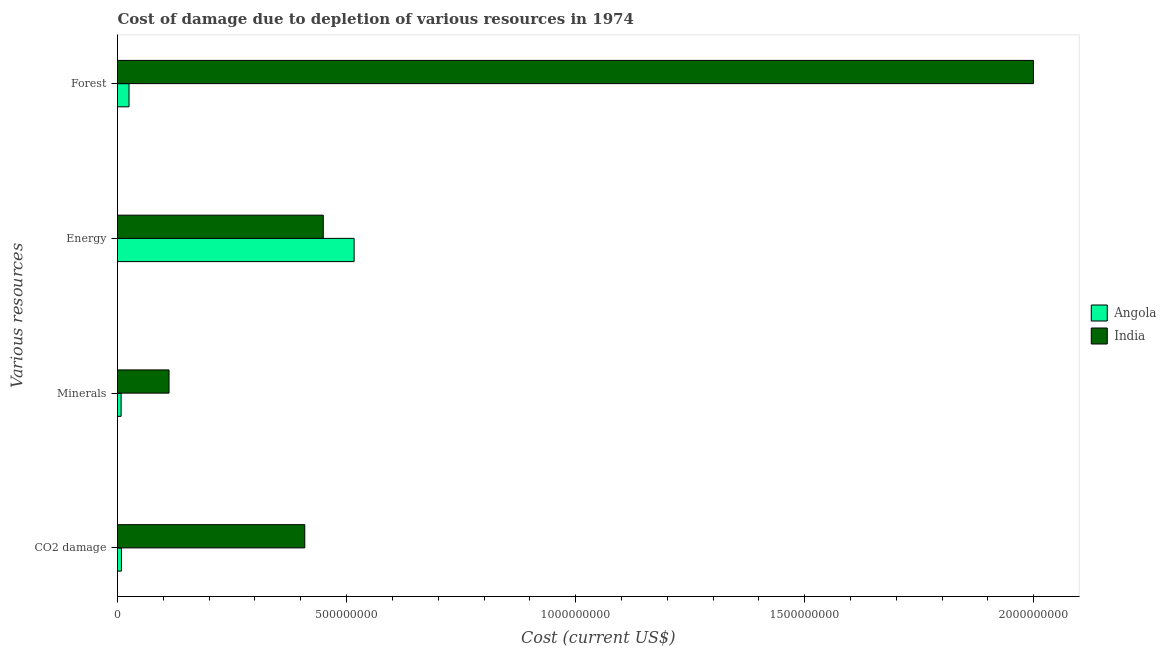How many different coloured bars are there?
Provide a succinct answer. 2. How many groups of bars are there?
Keep it short and to the point. 4. Are the number of bars per tick equal to the number of legend labels?
Offer a terse response. Yes. Are the number of bars on each tick of the Y-axis equal?
Your answer should be compact. Yes. How many bars are there on the 4th tick from the top?
Keep it short and to the point. 2. What is the label of the 3rd group of bars from the top?
Offer a very short reply. Minerals. What is the cost of damage due to depletion of energy in India?
Ensure brevity in your answer.  4.49e+08. Across all countries, what is the maximum cost of damage due to depletion of forests?
Give a very brief answer. 2.00e+09. Across all countries, what is the minimum cost of damage due to depletion of minerals?
Make the answer very short. 7.87e+06. In which country was the cost of damage due to depletion of energy maximum?
Your response must be concise. Angola. In which country was the cost of damage due to depletion of forests minimum?
Make the answer very short. Angola. What is the total cost of damage due to depletion of coal in the graph?
Your response must be concise. 4.17e+08. What is the difference between the cost of damage due to depletion of coal in India and that in Angola?
Keep it short and to the point. 4.00e+08. What is the difference between the cost of damage due to depletion of energy in India and the cost of damage due to depletion of forests in Angola?
Offer a terse response. 4.24e+08. What is the average cost of damage due to depletion of minerals per country?
Keep it short and to the point. 6.02e+07. What is the difference between the cost of damage due to depletion of energy and cost of damage due to depletion of forests in India?
Offer a very short reply. -1.55e+09. What is the ratio of the cost of damage due to depletion of coal in India to that in Angola?
Keep it short and to the point. 47.6. Is the cost of damage due to depletion of forests in Angola less than that in India?
Make the answer very short. Yes. Is the difference between the cost of damage due to depletion of minerals in Angola and India greater than the difference between the cost of damage due to depletion of forests in Angola and India?
Your answer should be very brief. Yes. What is the difference between the highest and the second highest cost of damage due to depletion of forests?
Your answer should be compact. 1.97e+09. What is the difference between the highest and the lowest cost of damage due to depletion of forests?
Your response must be concise. 1.97e+09. In how many countries, is the cost of damage due to depletion of coal greater than the average cost of damage due to depletion of coal taken over all countries?
Give a very brief answer. 1. Is the sum of the cost of damage due to depletion of minerals in India and Angola greater than the maximum cost of damage due to depletion of coal across all countries?
Offer a very short reply. No. What does the 2nd bar from the top in CO2 damage represents?
Your answer should be compact. Angola. What does the 1st bar from the bottom in Energy represents?
Ensure brevity in your answer.  Angola. Is it the case that in every country, the sum of the cost of damage due to depletion of coal and cost of damage due to depletion of minerals is greater than the cost of damage due to depletion of energy?
Provide a succinct answer. No. Are the values on the major ticks of X-axis written in scientific E-notation?
Keep it short and to the point. No. Where does the legend appear in the graph?
Your answer should be very brief. Center right. How many legend labels are there?
Make the answer very short. 2. What is the title of the graph?
Your answer should be very brief. Cost of damage due to depletion of various resources in 1974 . What is the label or title of the X-axis?
Ensure brevity in your answer.  Cost (current US$). What is the label or title of the Y-axis?
Ensure brevity in your answer.  Various resources. What is the Cost (current US$) of Angola in CO2 damage?
Ensure brevity in your answer.  8.59e+06. What is the Cost (current US$) of India in CO2 damage?
Provide a succinct answer. 4.09e+08. What is the Cost (current US$) of Angola in Minerals?
Ensure brevity in your answer.  7.87e+06. What is the Cost (current US$) of India in Minerals?
Give a very brief answer. 1.12e+08. What is the Cost (current US$) of Angola in Energy?
Offer a terse response. 5.16e+08. What is the Cost (current US$) in India in Energy?
Keep it short and to the point. 4.49e+08. What is the Cost (current US$) in Angola in Forest?
Make the answer very short. 2.51e+07. What is the Cost (current US$) in India in Forest?
Ensure brevity in your answer.  2.00e+09. Across all Various resources, what is the maximum Cost (current US$) in Angola?
Your answer should be compact. 5.16e+08. Across all Various resources, what is the maximum Cost (current US$) in India?
Your response must be concise. 2.00e+09. Across all Various resources, what is the minimum Cost (current US$) of Angola?
Provide a short and direct response. 7.87e+06. Across all Various resources, what is the minimum Cost (current US$) of India?
Offer a terse response. 1.12e+08. What is the total Cost (current US$) in Angola in the graph?
Provide a short and direct response. 5.58e+08. What is the total Cost (current US$) in India in the graph?
Offer a very short reply. 2.97e+09. What is the difference between the Cost (current US$) of Angola in CO2 damage and that in Minerals?
Ensure brevity in your answer.  7.21e+05. What is the difference between the Cost (current US$) of India in CO2 damage and that in Minerals?
Keep it short and to the point. 2.96e+08. What is the difference between the Cost (current US$) of Angola in CO2 damage and that in Energy?
Offer a terse response. -5.08e+08. What is the difference between the Cost (current US$) in India in CO2 damage and that in Energy?
Keep it short and to the point. -4.04e+07. What is the difference between the Cost (current US$) of Angola in CO2 damage and that in Forest?
Your answer should be compact. -1.65e+07. What is the difference between the Cost (current US$) of India in CO2 damage and that in Forest?
Make the answer very short. -1.59e+09. What is the difference between the Cost (current US$) of Angola in Minerals and that in Energy?
Offer a terse response. -5.09e+08. What is the difference between the Cost (current US$) in India in Minerals and that in Energy?
Your answer should be very brief. -3.37e+08. What is the difference between the Cost (current US$) of Angola in Minerals and that in Forest?
Provide a short and direct response. -1.73e+07. What is the difference between the Cost (current US$) of India in Minerals and that in Forest?
Your answer should be compact. -1.89e+09. What is the difference between the Cost (current US$) of Angola in Energy and that in Forest?
Your answer should be very brief. 4.91e+08. What is the difference between the Cost (current US$) of India in Energy and that in Forest?
Your response must be concise. -1.55e+09. What is the difference between the Cost (current US$) in Angola in CO2 damage and the Cost (current US$) in India in Minerals?
Make the answer very short. -1.04e+08. What is the difference between the Cost (current US$) in Angola in CO2 damage and the Cost (current US$) in India in Energy?
Provide a succinct answer. -4.41e+08. What is the difference between the Cost (current US$) of Angola in CO2 damage and the Cost (current US$) of India in Forest?
Keep it short and to the point. -1.99e+09. What is the difference between the Cost (current US$) in Angola in Minerals and the Cost (current US$) in India in Energy?
Provide a short and direct response. -4.41e+08. What is the difference between the Cost (current US$) in Angola in Minerals and the Cost (current US$) in India in Forest?
Provide a succinct answer. -1.99e+09. What is the difference between the Cost (current US$) in Angola in Energy and the Cost (current US$) in India in Forest?
Give a very brief answer. -1.48e+09. What is the average Cost (current US$) in Angola per Various resources?
Make the answer very short. 1.40e+08. What is the average Cost (current US$) of India per Various resources?
Ensure brevity in your answer.  7.42e+08. What is the difference between the Cost (current US$) in Angola and Cost (current US$) in India in CO2 damage?
Offer a terse response. -4.00e+08. What is the difference between the Cost (current US$) of Angola and Cost (current US$) of India in Minerals?
Give a very brief answer. -1.05e+08. What is the difference between the Cost (current US$) in Angola and Cost (current US$) in India in Energy?
Provide a short and direct response. 6.73e+07. What is the difference between the Cost (current US$) in Angola and Cost (current US$) in India in Forest?
Offer a terse response. -1.97e+09. What is the ratio of the Cost (current US$) of Angola in CO2 damage to that in Minerals?
Offer a very short reply. 1.09. What is the ratio of the Cost (current US$) in India in CO2 damage to that in Minerals?
Your response must be concise. 3.63. What is the ratio of the Cost (current US$) in Angola in CO2 damage to that in Energy?
Make the answer very short. 0.02. What is the ratio of the Cost (current US$) in India in CO2 damage to that in Energy?
Ensure brevity in your answer.  0.91. What is the ratio of the Cost (current US$) of Angola in CO2 damage to that in Forest?
Ensure brevity in your answer.  0.34. What is the ratio of the Cost (current US$) of India in CO2 damage to that in Forest?
Make the answer very short. 0.2. What is the ratio of the Cost (current US$) of Angola in Minerals to that in Energy?
Your response must be concise. 0.02. What is the ratio of the Cost (current US$) of India in Minerals to that in Energy?
Offer a terse response. 0.25. What is the ratio of the Cost (current US$) of Angola in Minerals to that in Forest?
Give a very brief answer. 0.31. What is the ratio of the Cost (current US$) in India in Minerals to that in Forest?
Provide a short and direct response. 0.06. What is the ratio of the Cost (current US$) in Angola in Energy to that in Forest?
Your response must be concise. 20.55. What is the ratio of the Cost (current US$) in India in Energy to that in Forest?
Your answer should be compact. 0.22. What is the difference between the highest and the second highest Cost (current US$) in Angola?
Offer a terse response. 4.91e+08. What is the difference between the highest and the second highest Cost (current US$) in India?
Your answer should be compact. 1.55e+09. What is the difference between the highest and the lowest Cost (current US$) of Angola?
Your response must be concise. 5.09e+08. What is the difference between the highest and the lowest Cost (current US$) of India?
Offer a very short reply. 1.89e+09. 